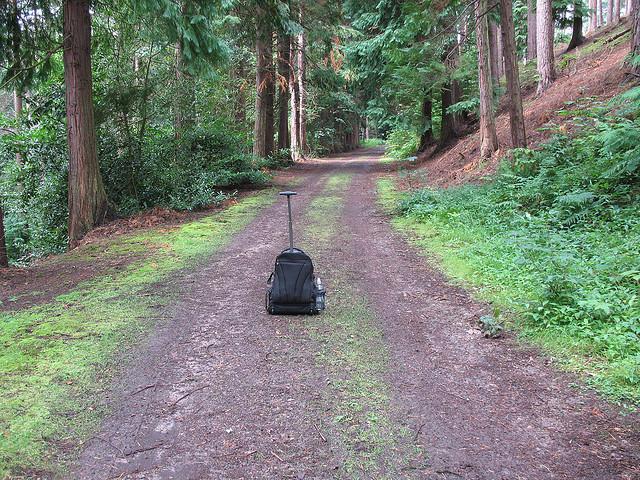What kind of tree is predominant in this picture?
Be succinct. Pine. Is that a dirt or paved road?
Give a very brief answer. Dirt. Is the ground flat?
Short answer required. Yes. 